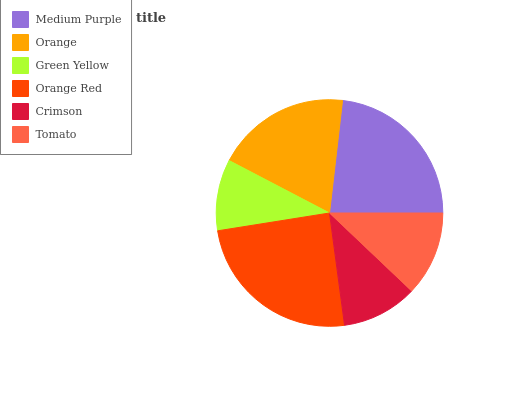Is Green Yellow the minimum?
Answer yes or no. Yes. Is Orange Red the maximum?
Answer yes or no. Yes. Is Orange the minimum?
Answer yes or no. No. Is Orange the maximum?
Answer yes or no. No. Is Medium Purple greater than Orange?
Answer yes or no. Yes. Is Orange less than Medium Purple?
Answer yes or no. Yes. Is Orange greater than Medium Purple?
Answer yes or no. No. Is Medium Purple less than Orange?
Answer yes or no. No. Is Orange the high median?
Answer yes or no. Yes. Is Tomato the low median?
Answer yes or no. Yes. Is Green Yellow the high median?
Answer yes or no. No. Is Crimson the low median?
Answer yes or no. No. 